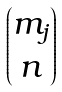Convert formula to latex. <formula><loc_0><loc_0><loc_500><loc_500>\begin{pmatrix} { m _ { j } } \\ n \end{pmatrix}</formula> 